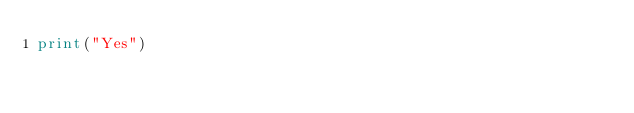<code> <loc_0><loc_0><loc_500><loc_500><_Python_>print("Yes")</code> 